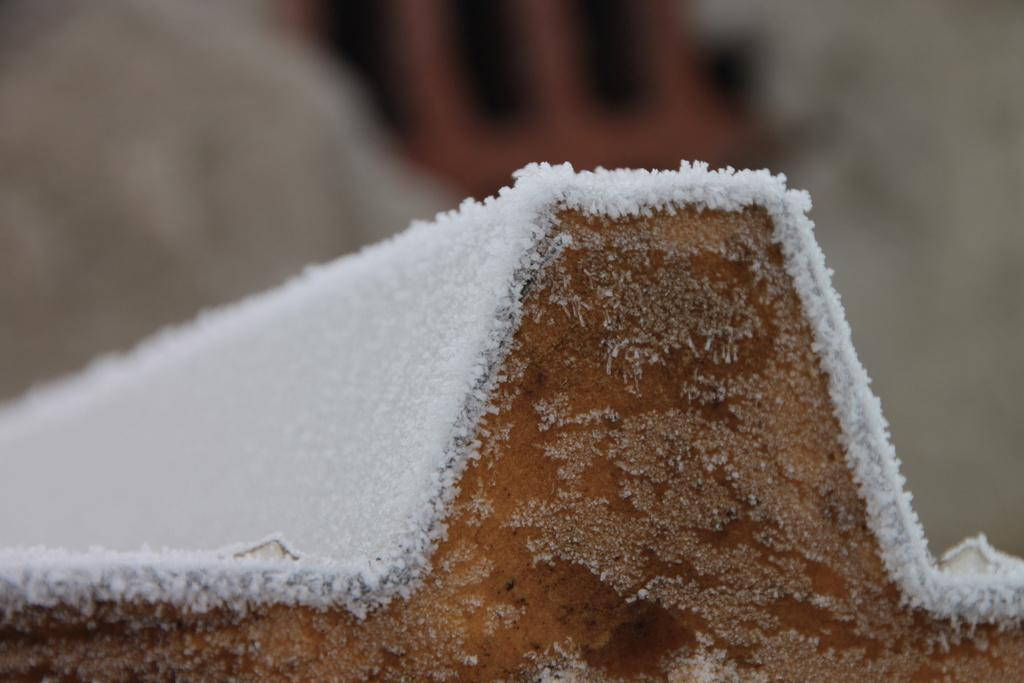What is the main subject in the image? There is an object in the image. Can you describe the appearance of the object? The object has a white color layer on it. What can be observed about the background of the image? The background of the image is blurred. What songs are being sung by the volcano in the image? There is no volcano present in the image, and therefore no songs can be heard or seen. What type of voyage is depicted in the image? There is no voyage depicted in the image; it features an object with a white color layer and a blurred background. 